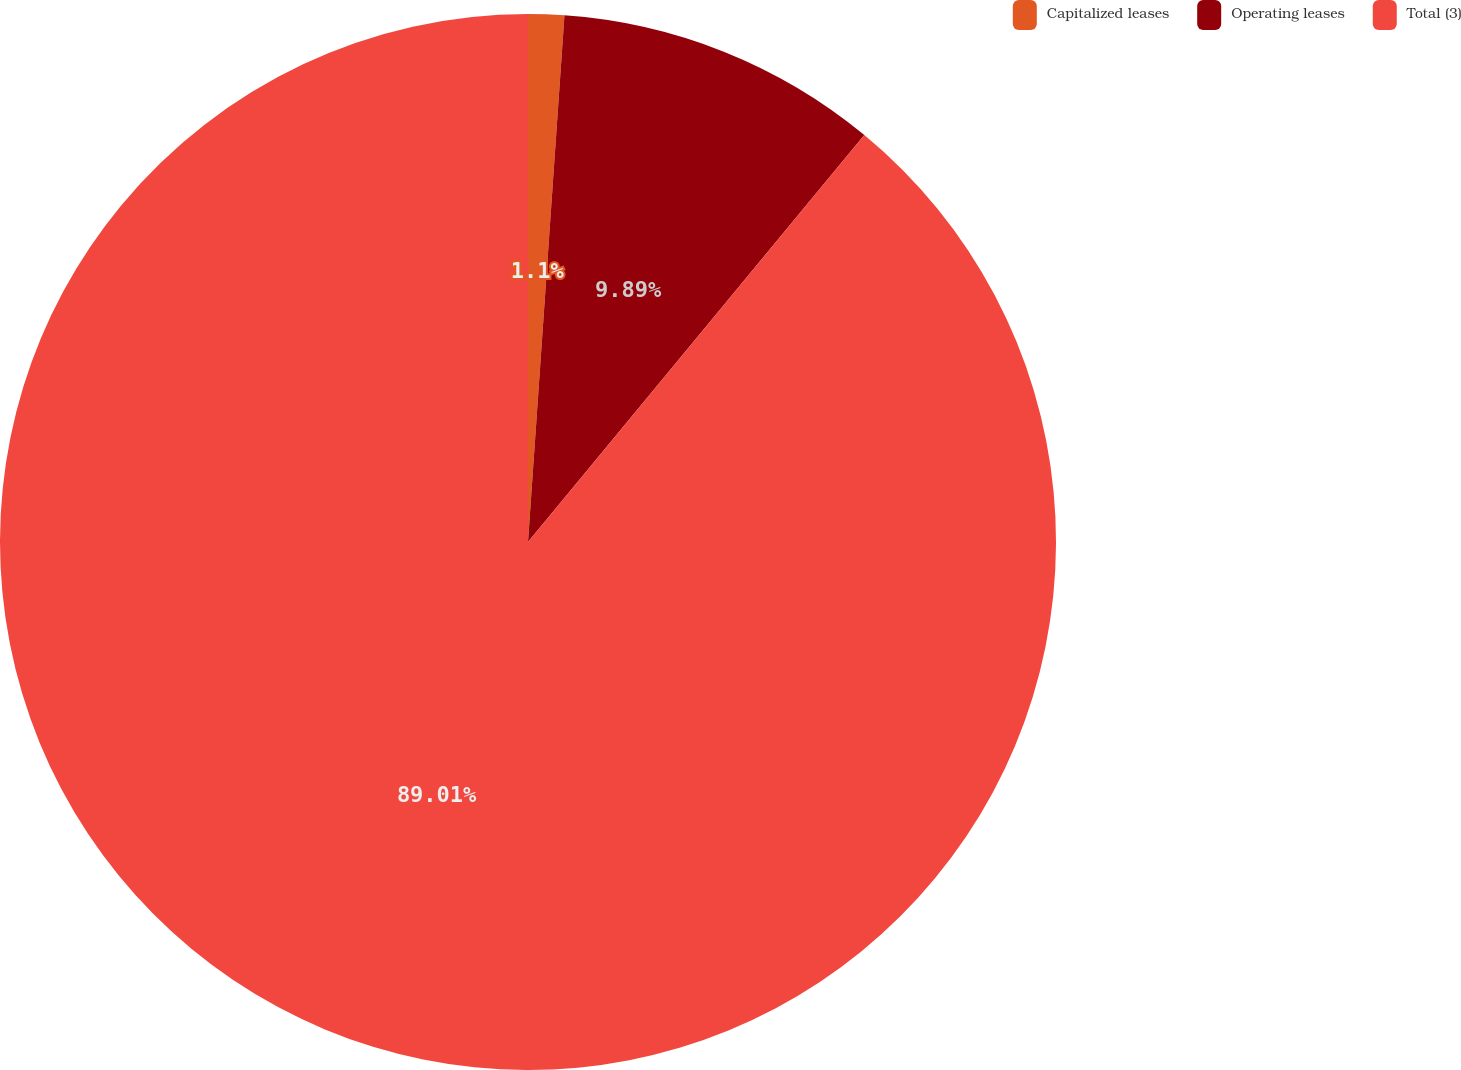Convert chart. <chart><loc_0><loc_0><loc_500><loc_500><pie_chart><fcel>Capitalized leases<fcel>Operating leases<fcel>Total (3)<nl><fcel>1.1%<fcel>9.89%<fcel>89.0%<nl></chart> 